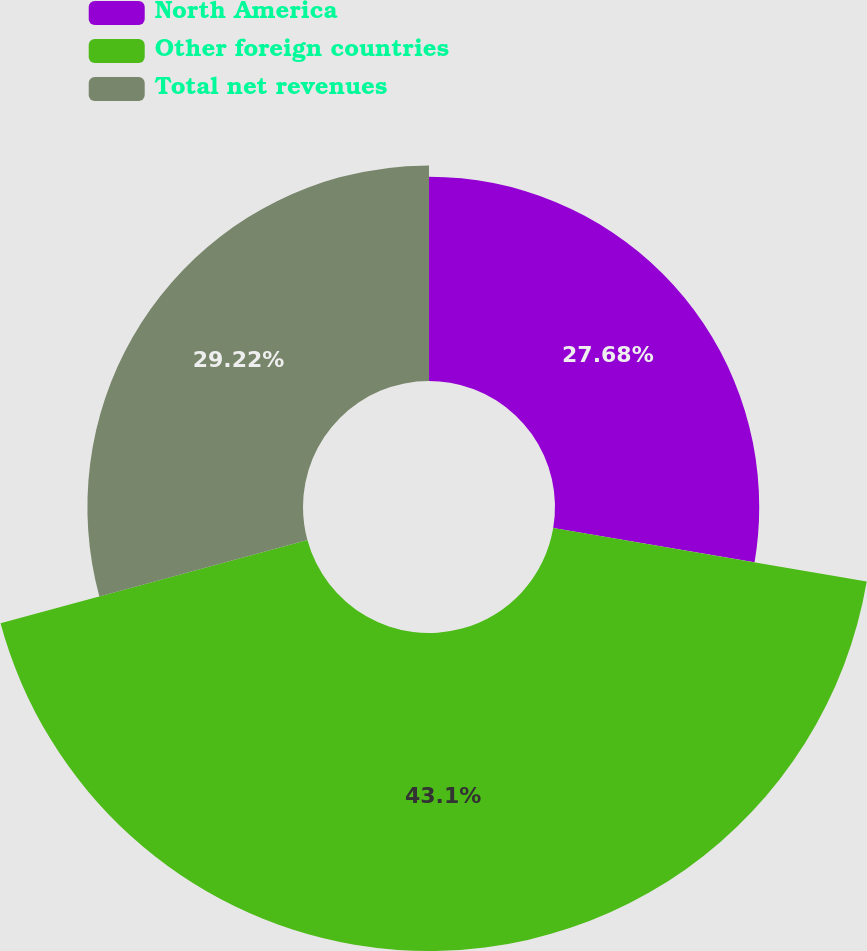Convert chart to OTSL. <chart><loc_0><loc_0><loc_500><loc_500><pie_chart><fcel>North America<fcel>Other foreign countries<fcel>Total net revenues<nl><fcel>27.68%<fcel>43.1%<fcel>29.22%<nl></chart> 